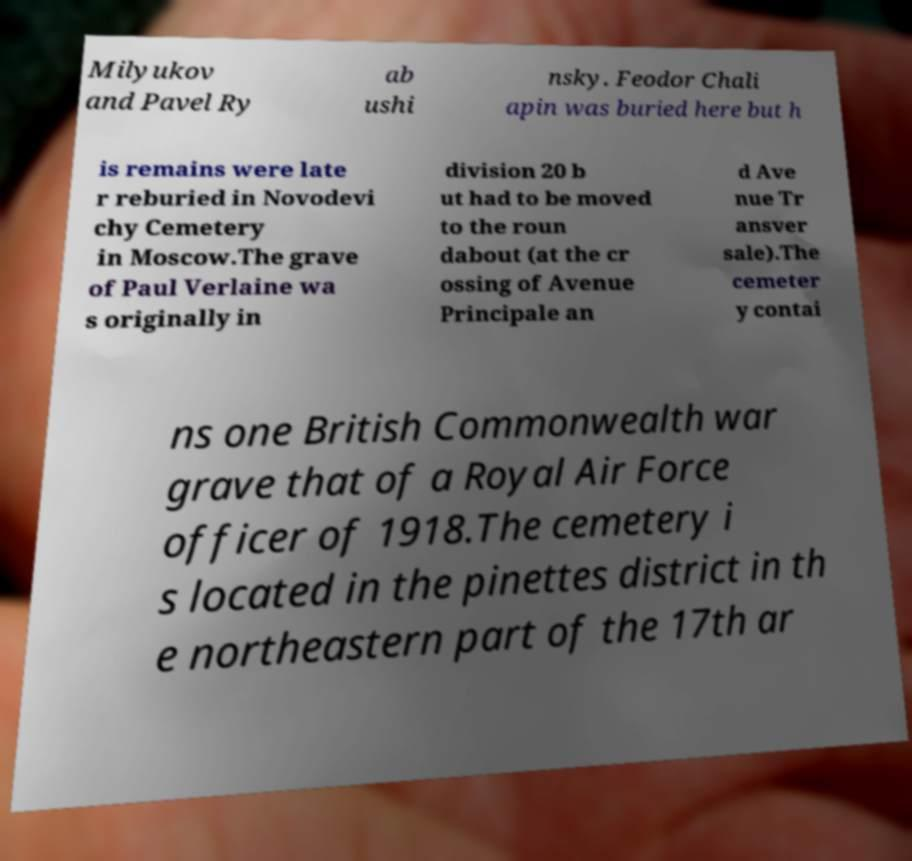Please identify and transcribe the text found in this image. Milyukov and Pavel Ry ab ushi nsky. Feodor Chali apin was buried here but h is remains were late r reburied in Novodevi chy Cemetery in Moscow.The grave of Paul Verlaine wa s originally in division 20 b ut had to be moved to the roun dabout (at the cr ossing of Avenue Principale an d Ave nue Tr ansver sale).The cemeter y contai ns one British Commonwealth war grave that of a Royal Air Force officer of 1918.The cemetery i s located in the pinettes district in th e northeastern part of the 17th ar 